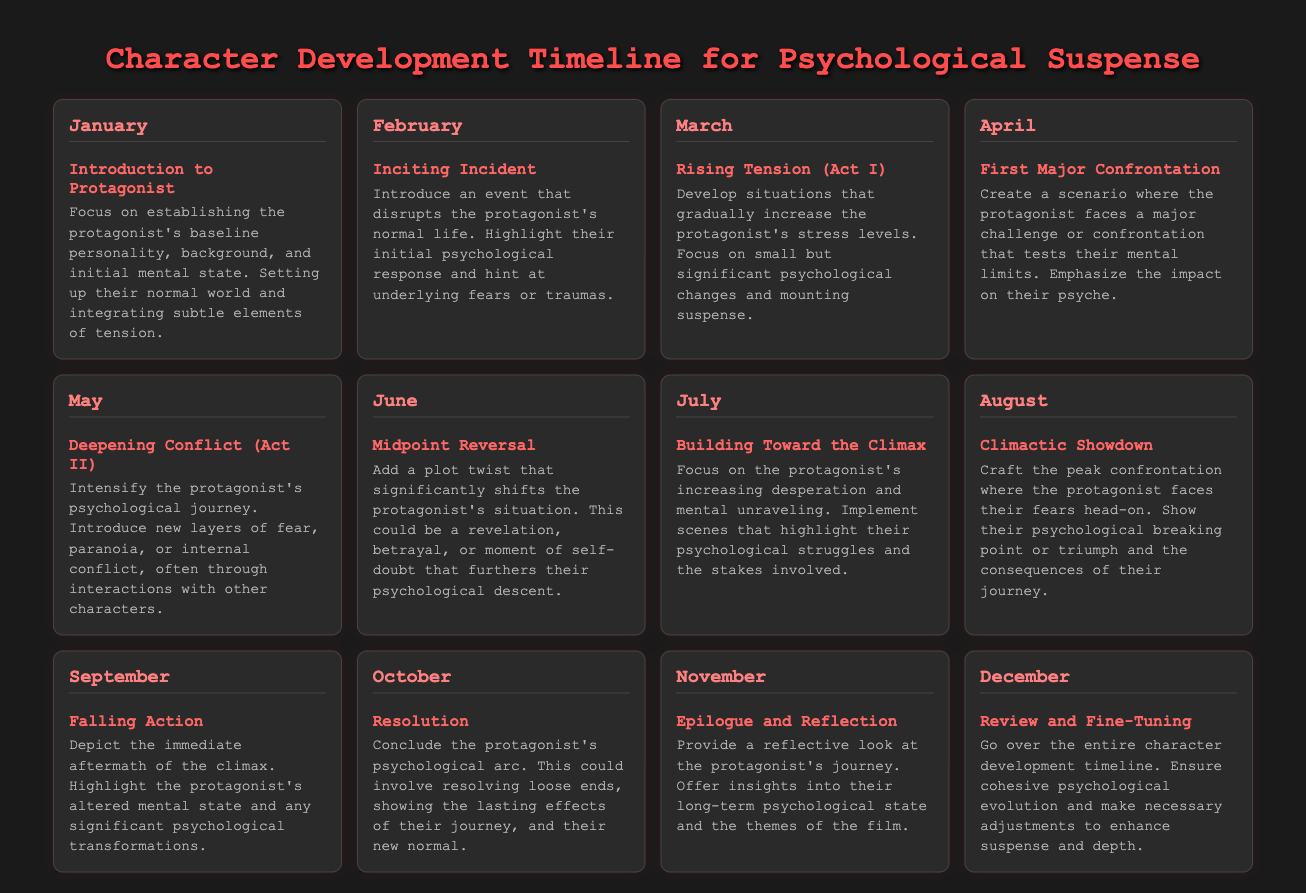What is the first milestone in the timeline? The first milestone listed is "Introduction to Protagonist" in January.
Answer: Introduction to Protagonist What month is the "Climactic Showdown" scheduled? The "Climactic Showdown" is scheduled for August.
Answer: August How many months are dedicated to character development? The document outlines character development milestones for twelve months.
Answer: Twelve What psychological change occurs in May? The month of May highlights "Deepening Conflict (Act II)".
Answer: Deepening Conflict (Act II) What event disrupts the protagonist's life in February? February features the milestone "Inciting Incident".
Answer: Inciting Incident In which month does the protagonist experience a "Midpoint Reversal"? According to the timeline, the "Midpoint Reversal" occurs in June.
Answer: June What is emphasized during the "Building Toward the Climax" month? The emphasis during July is on the protagonist's increasing desperation and mental unraveling.
Answer: Increasing desperation and mental unraveling What does the "Epilogue and Reflection" milestone provide? The "Epilogue and Reflection" milestone offers insights into the protagonist's long-term psychological state.
Answer: Insights into long-term psychological state Which month details the aftermath of the climax? The "Falling Action" occurs in September, detailing the aftermath of the climax.
Answer: September What is the main focus of the document? The document focuses on charting the psychological evolution of a character throughout the film.
Answer: Charting psychological evolution 